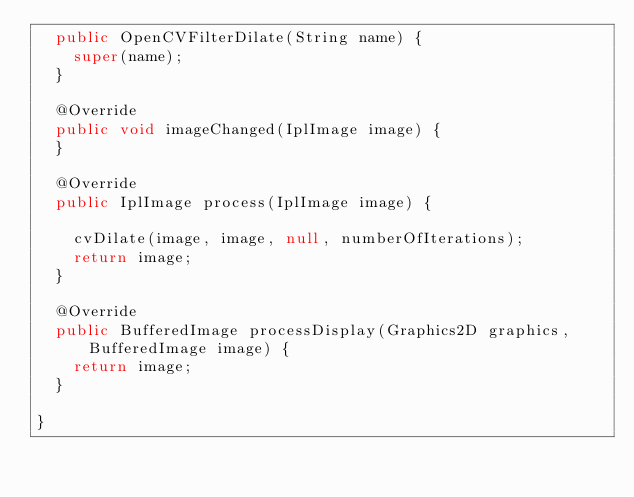<code> <loc_0><loc_0><loc_500><loc_500><_Java_>  public OpenCVFilterDilate(String name) {
    super(name);
  }

  @Override
  public void imageChanged(IplImage image) {
  }

  @Override
  public IplImage process(IplImage image) {

    cvDilate(image, image, null, numberOfIterations);
    return image;
  }

  @Override
  public BufferedImage processDisplay(Graphics2D graphics, BufferedImage image) {
    return image;
  }

}
</code> 